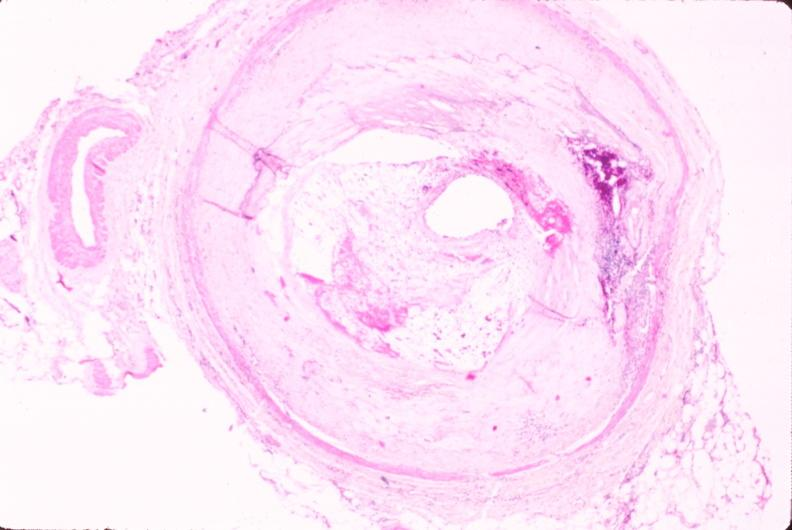what left anterior descending coronary artery?
Answer the question using a single word or phrase. Atherosclerosis 